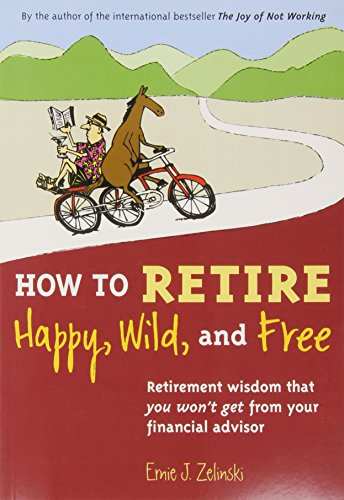What are some key advice points that the book offers for a happy retirement? The book emphasizes the importance of financial independence, creative self-expression, maintaining social connections, and staying physically and mentally active to enjoy a fulfilling retirement. 